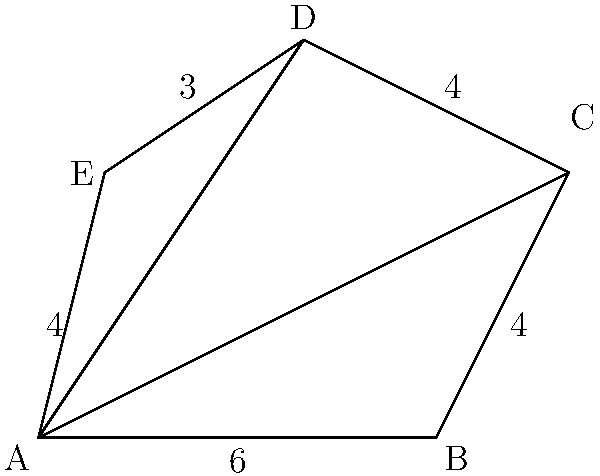Given the irregular pentagon ABCDE, calculate its area using triangulation. The side lengths are: AB = 6, BC = 4, CD = 4, DE = 3, and EA = 4. How would you approach this problem using computational geometry principles, and what is the final area? To calculate the area of this irregular pentagon using triangulation, we'll follow these steps:

1) Divide the pentagon into three triangles: ABC, ACD, and ADE.

2) Calculate the area of each triangle using Heron's formula:
   $A = \sqrt{s(s-a)(s-b)(s-c)}$
   where $s = \frac{a+b+c}{2}$ (semi-perimeter) and $a$, $b$, $c$ are side lengths.

3) For triangle ABC:
   AC = $\sqrt{6^2 + 4^2} = \sqrt{52} = 7.21$ (using Pythagorean theorem)
   $s = \frac{6 + 4 + 7.21}{2} = 8.61$
   $A_{ABC} = \sqrt{8.61(8.61-6)(8.61-4)(8.61-7.21)} = 11.98$

4) For triangle ACD:
   AD = $\sqrt{4^2 + 6^2} = \sqrt{52} = 7.21$
   $s = \frac{7.21 + 4 + 7.21}{2} = 9.21$
   $A_{ACD} = \sqrt{9.21(9.21-7.21)(9.21-4)(9.21-7.21)} = 14.42$

5) For triangle ADE:
   $s = \frac{7.21 + 3 + 4}{2} = 7.11$
   $A_{ADE} = \sqrt{7.11(7.11-7.21)(7.11-3)(7.11-4)} = 5.66$

6) The total area is the sum of these three triangles:
   $A_{total} = A_{ABC} + A_{ACD} + A_{ADE} = 11.98 + 14.42 + 5.66 = 32.06$

This approach demonstrates the application of computational geometry principles, specifically triangulation and the use of Heron's formula, to solve complex area calculations.
Answer: 32.06 square units 